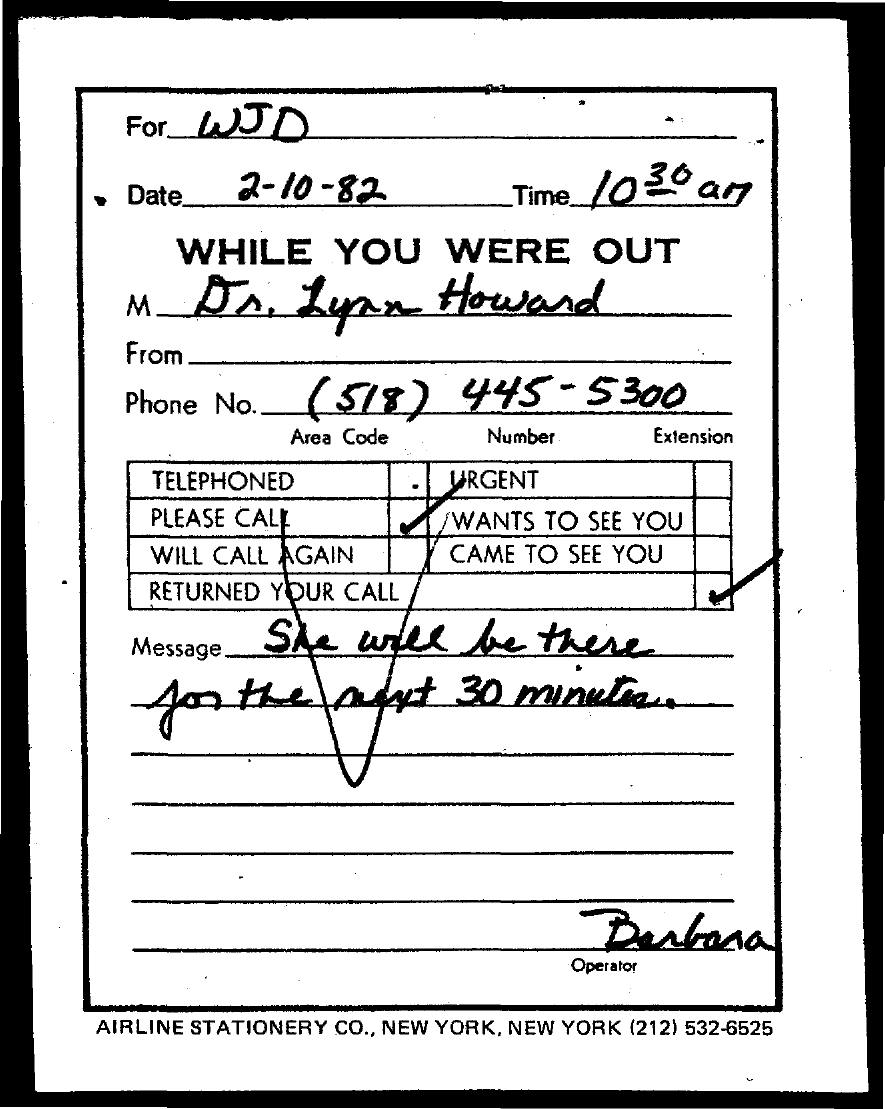Who is the operator mentioned in the document?
Your answer should be very brief. Barbara. To whom, the message is send?
Provide a short and direct response. WJD. What is the phone no. of Dr. Lynn Howard?
Your response must be concise. (518) 445-5300. What is the content of the message sent?
Your answer should be compact. She will be there for the next 30 minutes. 